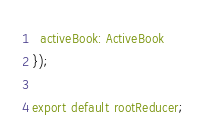Convert code to text. <code><loc_0><loc_0><loc_500><loc_500><_JavaScript_>  activeBook: ActiveBook
});

export default rootReducer;
</code> 